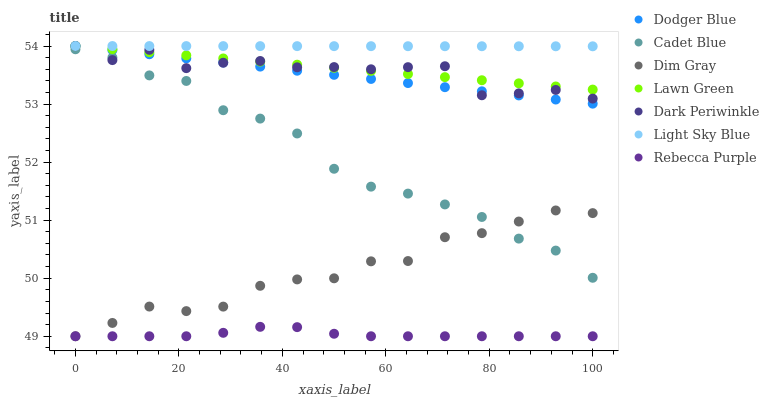Does Rebecca Purple have the minimum area under the curve?
Answer yes or no. Yes. Does Light Sky Blue have the maximum area under the curve?
Answer yes or no. Yes. Does Dim Gray have the minimum area under the curve?
Answer yes or no. No. Does Dim Gray have the maximum area under the curve?
Answer yes or no. No. Is Lawn Green the smoothest?
Answer yes or no. Yes. Is Dark Periwinkle the roughest?
Answer yes or no. Yes. Is Dim Gray the smoothest?
Answer yes or no. No. Is Dim Gray the roughest?
Answer yes or no. No. Does Dim Gray have the lowest value?
Answer yes or no. Yes. Does Cadet Blue have the lowest value?
Answer yes or no. No. Does Dark Periwinkle have the highest value?
Answer yes or no. Yes. Does Dim Gray have the highest value?
Answer yes or no. No. Is Cadet Blue less than Lawn Green?
Answer yes or no. Yes. Is Light Sky Blue greater than Rebecca Purple?
Answer yes or no. Yes. Does Cadet Blue intersect Dim Gray?
Answer yes or no. Yes. Is Cadet Blue less than Dim Gray?
Answer yes or no. No. Is Cadet Blue greater than Dim Gray?
Answer yes or no. No. Does Cadet Blue intersect Lawn Green?
Answer yes or no. No. 